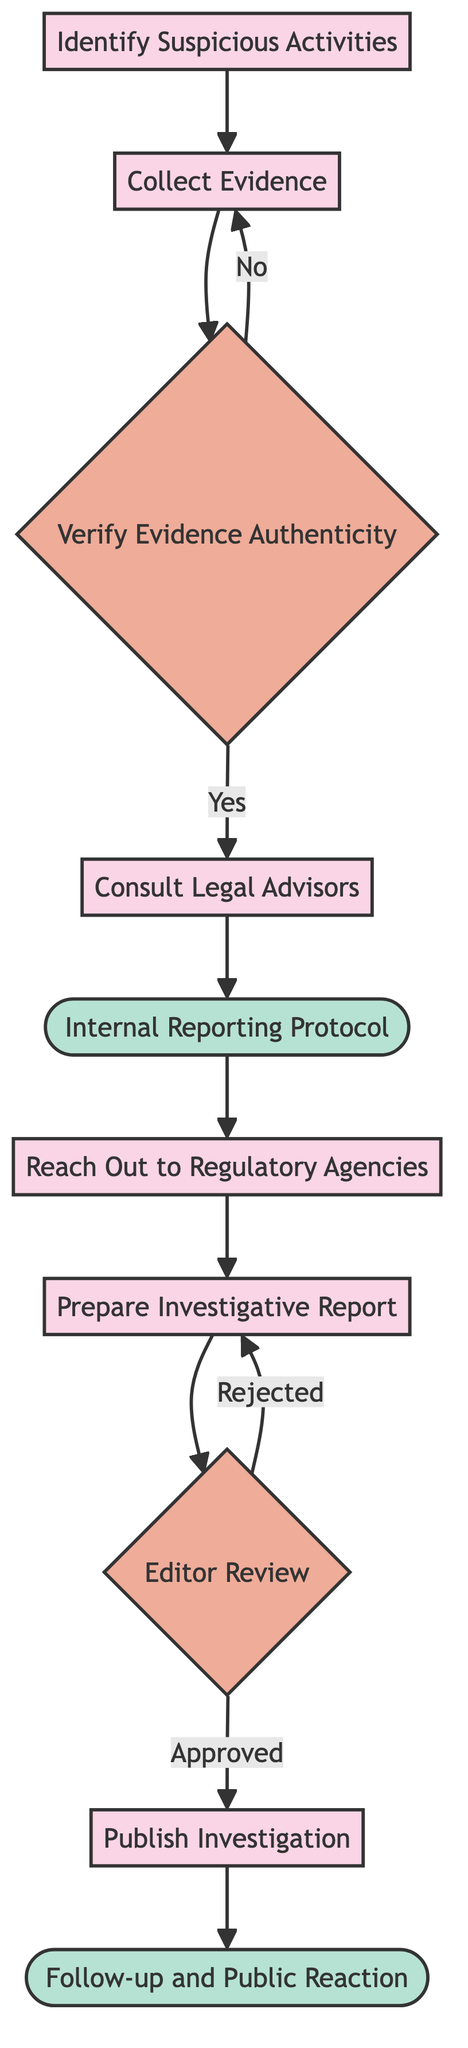What is the first action in the flow chart? The first action is "Identify Suspicious Activities," which is the starting point of the flow chart where monitoring hotel operations begins for any irregularities.
Answer: Identify Suspicious Activities How many decision nodes are in the diagram? The flow chart contains 2 decision nodes: "Verify Evidence Authenticity" and "Editor Review." These are the points where a choice must be made based on the information presented.
Answer: 2 What happens if the evidence authenticity is verified as "No"? If the evidence authenticity is verified as "No," the process will loop back to "Collect Evidence," requiring the evidence to be re-collected before proceeding.
Answer: Re-collect evidence What is the last action that occurs in the flow chart? The last action in the flow chart is "Follow-up and Public Reaction," which occurs after the investigation has been published, indicating the final step of monitoring the public and corporate responses.
Answer: Follow-up and Public Reaction What is required before publishing the investigation? Before publishing the investigation, the report must go through "Editor Review." If approved, it can be published; if rejected, it will need to be revised.
Answer: Editor Review 